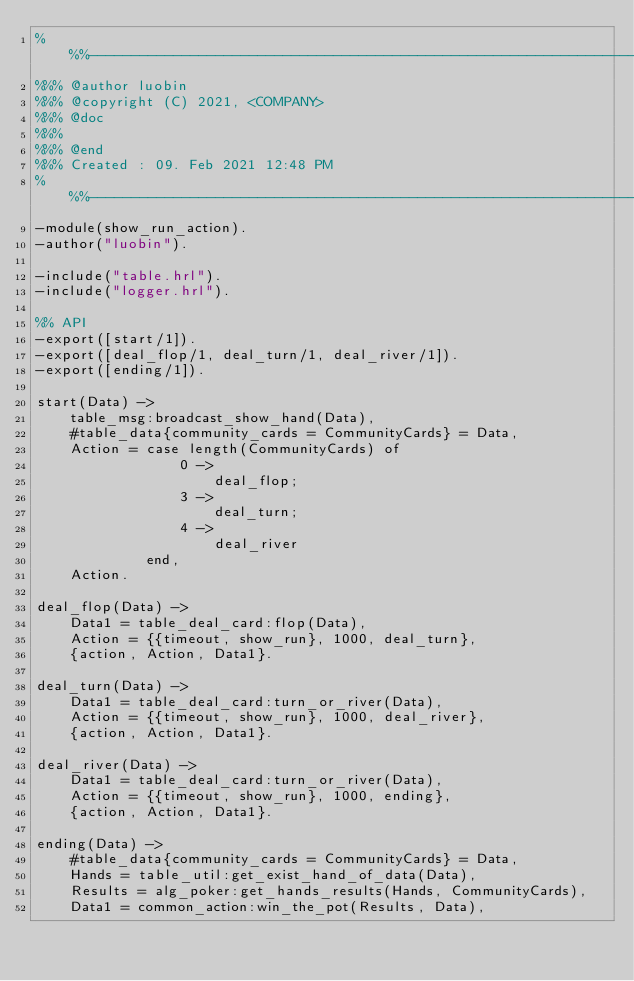Convert code to text. <code><loc_0><loc_0><loc_500><loc_500><_Erlang_>%%%-------------------------------------------------------------------
%%% @author luobin
%%% @copyright (C) 2021, <COMPANY>
%%% @doc
%%%
%%% @end
%%% Created : 09. Feb 2021 12:48 PM
%%%-------------------------------------------------------------------
-module(show_run_action).
-author("luobin").

-include("table.hrl").
-include("logger.hrl").

%% API
-export([start/1]).
-export([deal_flop/1, deal_turn/1, deal_river/1]).
-export([ending/1]).

start(Data) ->
    table_msg:broadcast_show_hand(Data),
    #table_data{community_cards = CommunityCards} = Data,
    Action = case length(CommunityCards) of
                 0 ->
                     deal_flop;
                 3 ->
                     deal_turn;
                 4 ->
                     deal_river
             end,
    Action.

deal_flop(Data) ->
    Data1 = table_deal_card:flop(Data),
    Action = {{timeout, show_run}, 1000, deal_turn},
    {action, Action, Data1}.

deal_turn(Data) ->
    Data1 = table_deal_card:turn_or_river(Data),
    Action = {{timeout, show_run}, 1000, deal_river},
    {action, Action, Data1}.

deal_river(Data) ->
    Data1 = table_deal_card:turn_or_river(Data),
    Action = {{timeout, show_run}, 1000, ending},
    {action, Action, Data1}.

ending(Data) ->
    #table_data{community_cards = CommunityCards} = Data,
    Hands = table_util:get_exist_hand_of_data(Data),
    Results = alg_poker:get_hands_results(Hands, CommunityCards),
    Data1 = common_action:win_the_pot(Results, Data),</code> 